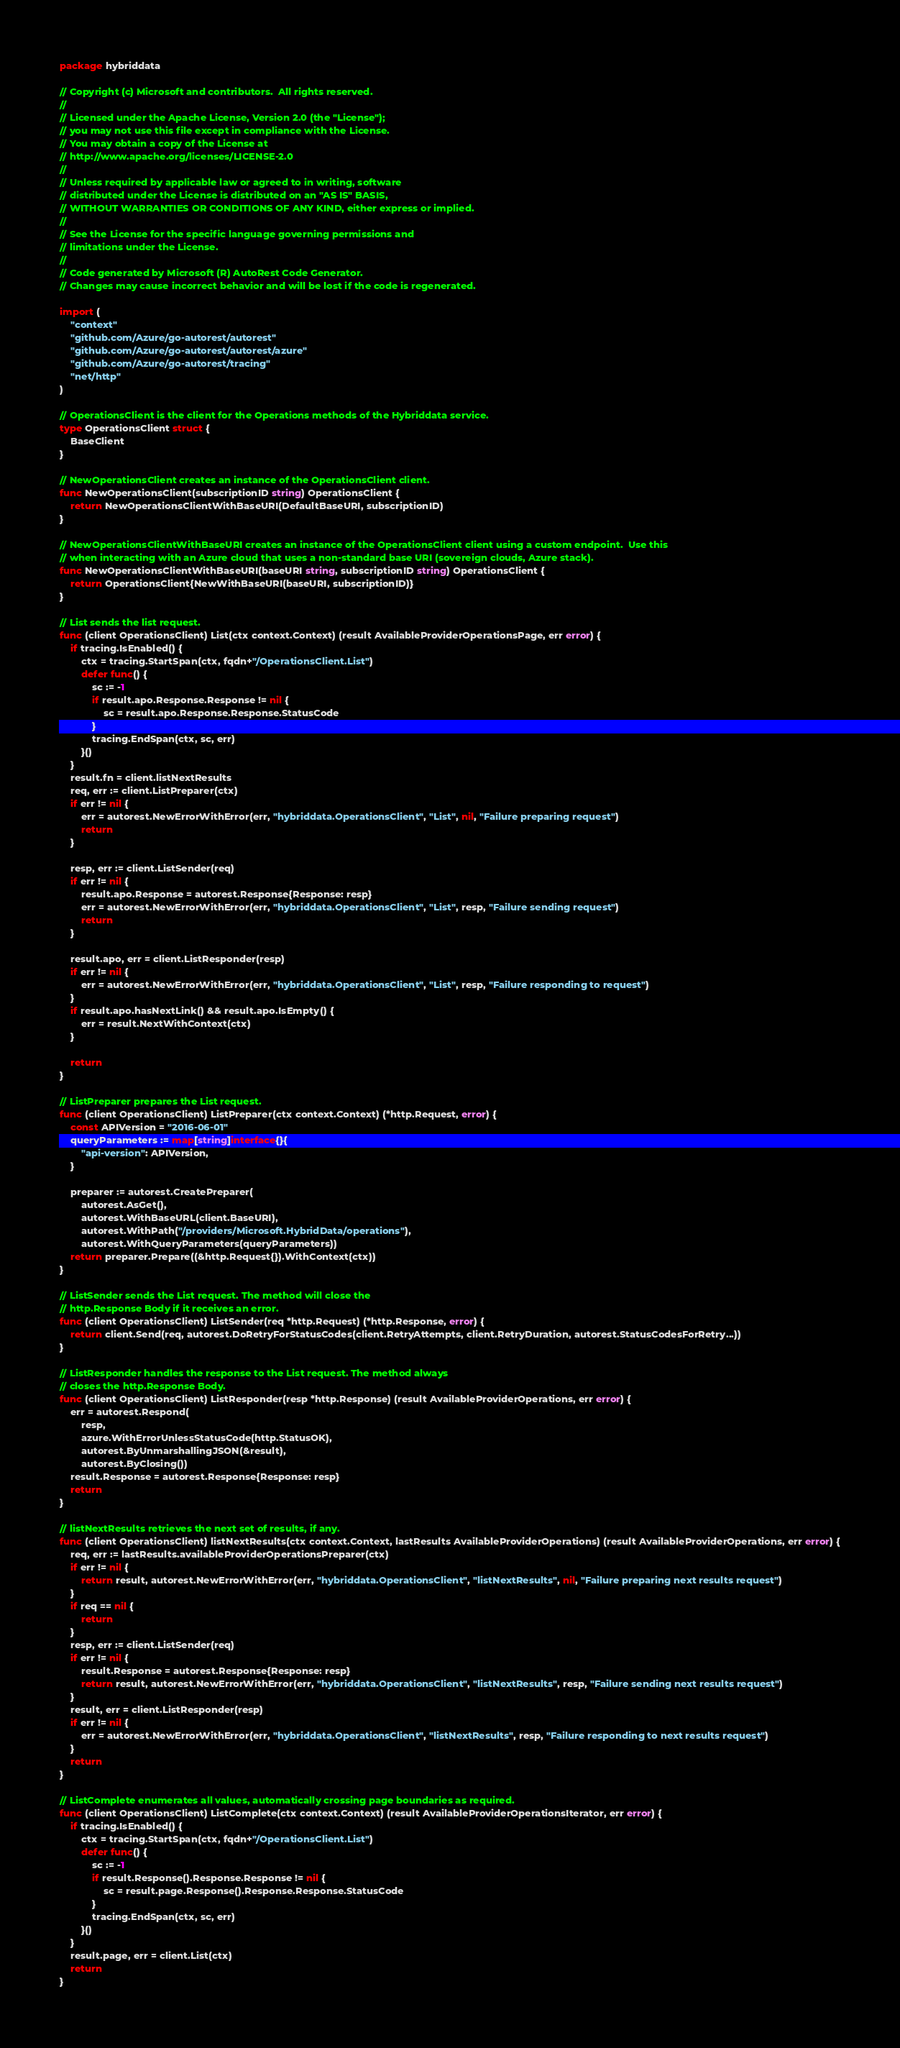Convert code to text. <code><loc_0><loc_0><loc_500><loc_500><_Go_>package hybriddata

// Copyright (c) Microsoft and contributors.  All rights reserved.
//
// Licensed under the Apache License, Version 2.0 (the "License");
// you may not use this file except in compliance with the License.
// You may obtain a copy of the License at
// http://www.apache.org/licenses/LICENSE-2.0
//
// Unless required by applicable law or agreed to in writing, software
// distributed under the License is distributed on an "AS IS" BASIS,
// WITHOUT WARRANTIES OR CONDITIONS OF ANY KIND, either express or implied.
//
// See the License for the specific language governing permissions and
// limitations under the License.
//
// Code generated by Microsoft (R) AutoRest Code Generator.
// Changes may cause incorrect behavior and will be lost if the code is regenerated.

import (
	"context"
	"github.com/Azure/go-autorest/autorest"
	"github.com/Azure/go-autorest/autorest/azure"
	"github.com/Azure/go-autorest/tracing"
	"net/http"
)

// OperationsClient is the client for the Operations methods of the Hybriddata service.
type OperationsClient struct {
	BaseClient
}

// NewOperationsClient creates an instance of the OperationsClient client.
func NewOperationsClient(subscriptionID string) OperationsClient {
	return NewOperationsClientWithBaseURI(DefaultBaseURI, subscriptionID)
}

// NewOperationsClientWithBaseURI creates an instance of the OperationsClient client using a custom endpoint.  Use this
// when interacting with an Azure cloud that uses a non-standard base URI (sovereign clouds, Azure stack).
func NewOperationsClientWithBaseURI(baseURI string, subscriptionID string) OperationsClient {
	return OperationsClient{NewWithBaseURI(baseURI, subscriptionID)}
}

// List sends the list request.
func (client OperationsClient) List(ctx context.Context) (result AvailableProviderOperationsPage, err error) {
	if tracing.IsEnabled() {
		ctx = tracing.StartSpan(ctx, fqdn+"/OperationsClient.List")
		defer func() {
			sc := -1
			if result.apo.Response.Response != nil {
				sc = result.apo.Response.Response.StatusCode
			}
			tracing.EndSpan(ctx, sc, err)
		}()
	}
	result.fn = client.listNextResults
	req, err := client.ListPreparer(ctx)
	if err != nil {
		err = autorest.NewErrorWithError(err, "hybriddata.OperationsClient", "List", nil, "Failure preparing request")
		return
	}

	resp, err := client.ListSender(req)
	if err != nil {
		result.apo.Response = autorest.Response{Response: resp}
		err = autorest.NewErrorWithError(err, "hybriddata.OperationsClient", "List", resp, "Failure sending request")
		return
	}

	result.apo, err = client.ListResponder(resp)
	if err != nil {
		err = autorest.NewErrorWithError(err, "hybriddata.OperationsClient", "List", resp, "Failure responding to request")
	}
	if result.apo.hasNextLink() && result.apo.IsEmpty() {
		err = result.NextWithContext(ctx)
	}

	return
}

// ListPreparer prepares the List request.
func (client OperationsClient) ListPreparer(ctx context.Context) (*http.Request, error) {
	const APIVersion = "2016-06-01"
	queryParameters := map[string]interface{}{
		"api-version": APIVersion,
	}

	preparer := autorest.CreatePreparer(
		autorest.AsGet(),
		autorest.WithBaseURL(client.BaseURI),
		autorest.WithPath("/providers/Microsoft.HybridData/operations"),
		autorest.WithQueryParameters(queryParameters))
	return preparer.Prepare((&http.Request{}).WithContext(ctx))
}

// ListSender sends the List request. The method will close the
// http.Response Body if it receives an error.
func (client OperationsClient) ListSender(req *http.Request) (*http.Response, error) {
	return client.Send(req, autorest.DoRetryForStatusCodes(client.RetryAttempts, client.RetryDuration, autorest.StatusCodesForRetry...))
}

// ListResponder handles the response to the List request. The method always
// closes the http.Response Body.
func (client OperationsClient) ListResponder(resp *http.Response) (result AvailableProviderOperations, err error) {
	err = autorest.Respond(
		resp,
		azure.WithErrorUnlessStatusCode(http.StatusOK),
		autorest.ByUnmarshallingJSON(&result),
		autorest.ByClosing())
	result.Response = autorest.Response{Response: resp}
	return
}

// listNextResults retrieves the next set of results, if any.
func (client OperationsClient) listNextResults(ctx context.Context, lastResults AvailableProviderOperations) (result AvailableProviderOperations, err error) {
	req, err := lastResults.availableProviderOperationsPreparer(ctx)
	if err != nil {
		return result, autorest.NewErrorWithError(err, "hybriddata.OperationsClient", "listNextResults", nil, "Failure preparing next results request")
	}
	if req == nil {
		return
	}
	resp, err := client.ListSender(req)
	if err != nil {
		result.Response = autorest.Response{Response: resp}
		return result, autorest.NewErrorWithError(err, "hybriddata.OperationsClient", "listNextResults", resp, "Failure sending next results request")
	}
	result, err = client.ListResponder(resp)
	if err != nil {
		err = autorest.NewErrorWithError(err, "hybriddata.OperationsClient", "listNextResults", resp, "Failure responding to next results request")
	}
	return
}

// ListComplete enumerates all values, automatically crossing page boundaries as required.
func (client OperationsClient) ListComplete(ctx context.Context) (result AvailableProviderOperationsIterator, err error) {
	if tracing.IsEnabled() {
		ctx = tracing.StartSpan(ctx, fqdn+"/OperationsClient.List")
		defer func() {
			sc := -1
			if result.Response().Response.Response != nil {
				sc = result.page.Response().Response.Response.StatusCode
			}
			tracing.EndSpan(ctx, sc, err)
		}()
	}
	result.page, err = client.List(ctx)
	return
}
</code> 